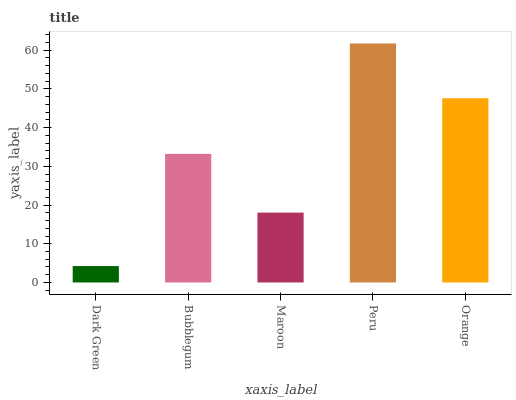Is Dark Green the minimum?
Answer yes or no. Yes. Is Peru the maximum?
Answer yes or no. Yes. Is Bubblegum the minimum?
Answer yes or no. No. Is Bubblegum the maximum?
Answer yes or no. No. Is Bubblegum greater than Dark Green?
Answer yes or no. Yes. Is Dark Green less than Bubblegum?
Answer yes or no. Yes. Is Dark Green greater than Bubblegum?
Answer yes or no. No. Is Bubblegum less than Dark Green?
Answer yes or no. No. Is Bubblegum the high median?
Answer yes or no. Yes. Is Bubblegum the low median?
Answer yes or no. Yes. Is Dark Green the high median?
Answer yes or no. No. Is Maroon the low median?
Answer yes or no. No. 